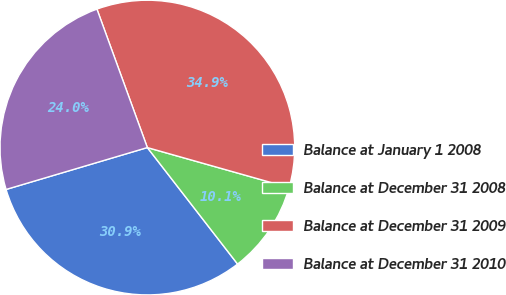Convert chart. <chart><loc_0><loc_0><loc_500><loc_500><pie_chart><fcel>Balance at January 1 2008<fcel>Balance at December 31 2008<fcel>Balance at December 31 2009<fcel>Balance at December 31 2010<nl><fcel>30.9%<fcel>10.13%<fcel>34.94%<fcel>24.03%<nl></chart> 